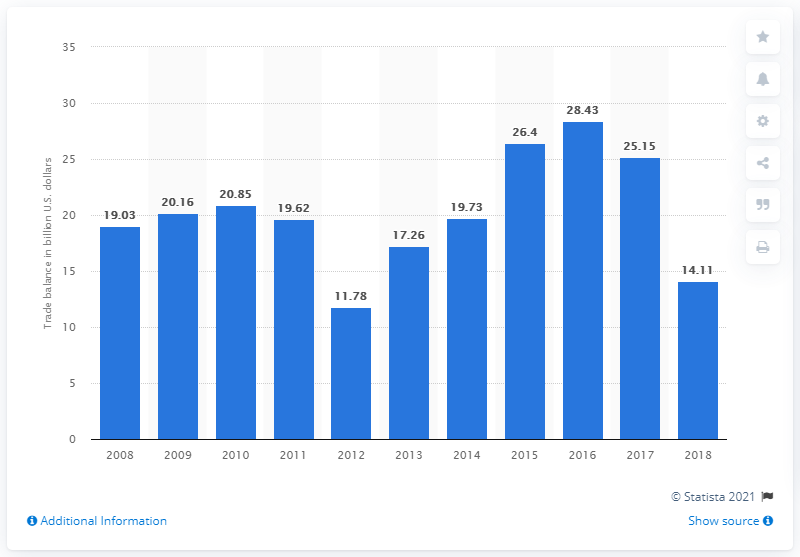Identify some key points in this picture. In 2018, Puerto Rico's trade surplus was 14.11. 